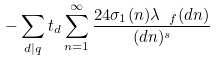<formula> <loc_0><loc_0><loc_500><loc_500>- \sum _ { d | q } t _ { d } \sum _ { n = 1 } ^ { \infty } \frac { 2 4 \sigma _ { 1 } ( n ) \lambda _ { \ f } ( d n ) } { ( d n ) ^ { s } }</formula> 